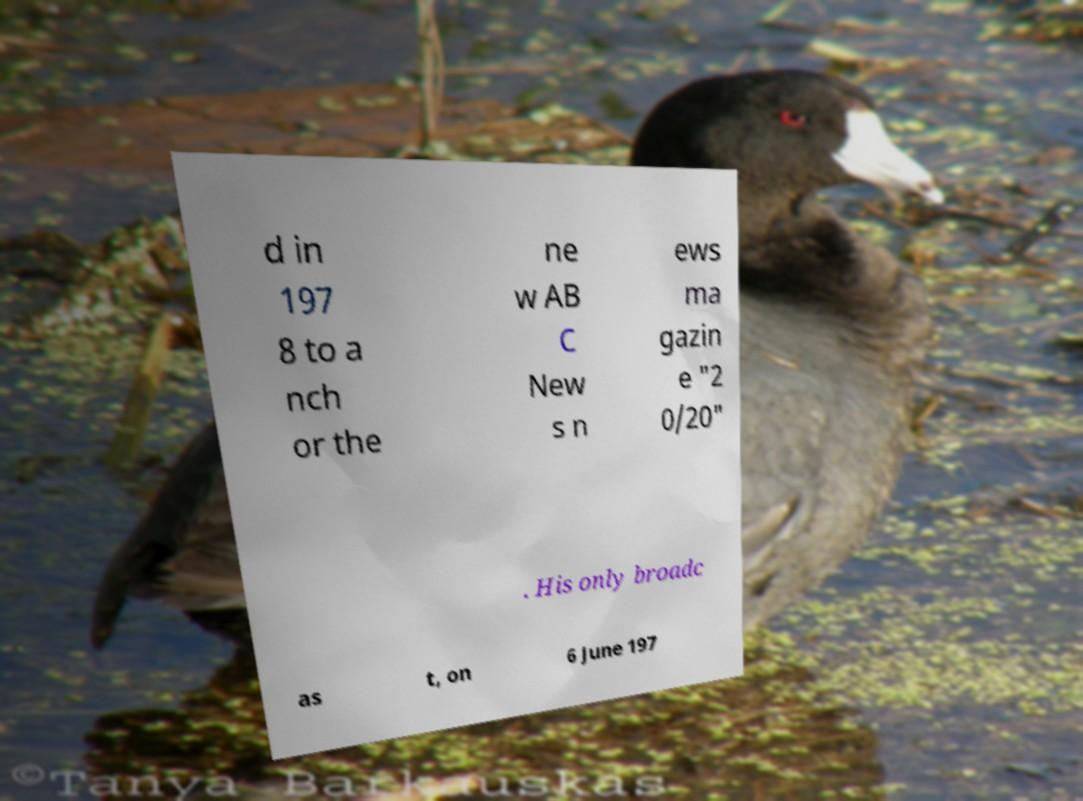There's text embedded in this image that I need extracted. Can you transcribe it verbatim? d in 197 8 to a nch or the ne w AB C New s n ews ma gazin e "2 0/20" . His only broadc as t, on 6 June 197 